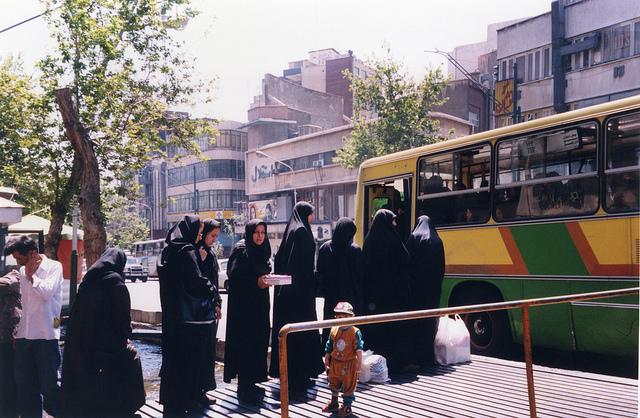What colors are the bus?
Answer briefly. Yellow, green, red. Are these women waiting for people to get off the bus?
Write a very short answer. Yes. Are all the women in line wearing black gowns?
Give a very brief answer. Yes. 